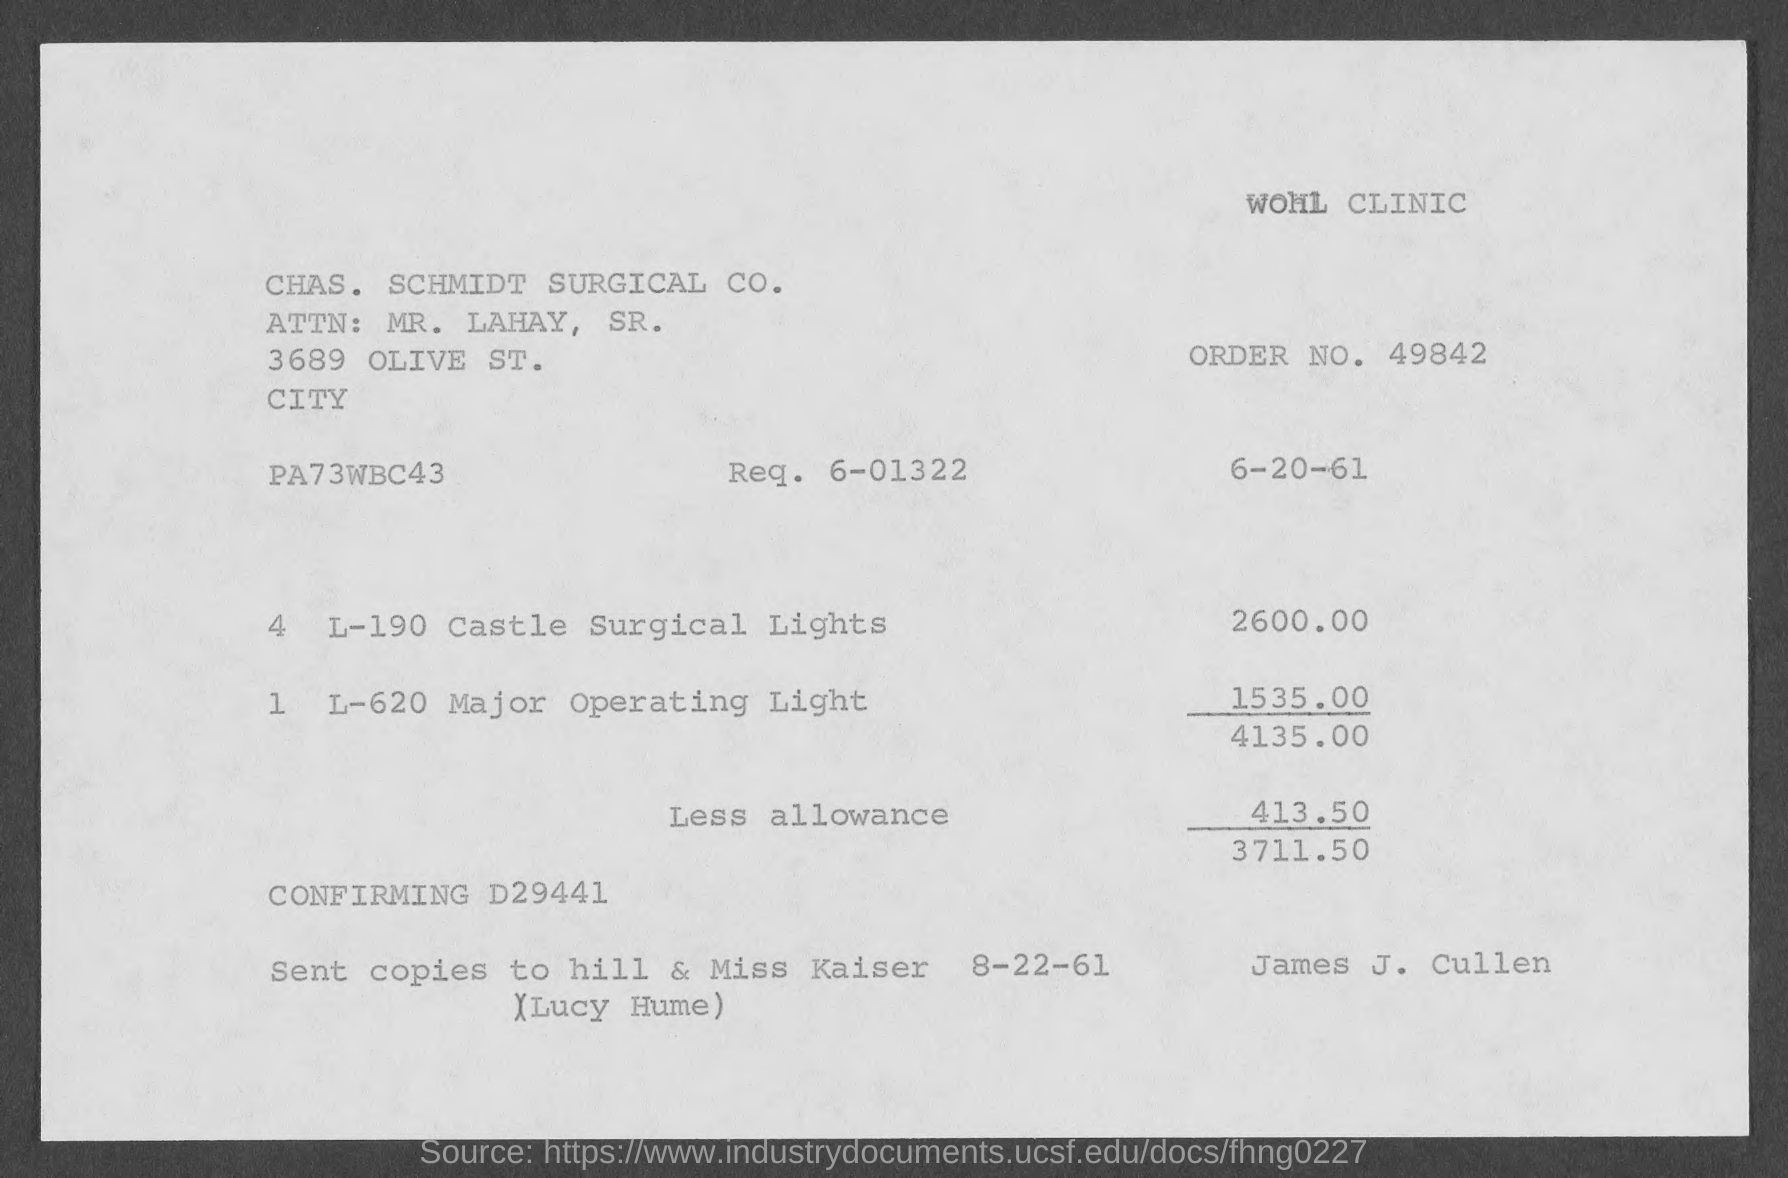Can you provide the date when this invoice was issued and any specific mention of whom it was sent to? The invoice is dated 6-20-61, so it presumably was issued on June 20th, 1961. It mentions that copies were sent to Hill & Miss Kaiser on 8-22-61, with a note added referencing Lucy Hume. 